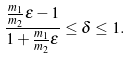Convert formula to latex. <formula><loc_0><loc_0><loc_500><loc_500>\frac { \frac { m _ { 1 } } { m _ { 2 } } \varepsilon - 1 } { 1 + \frac { m _ { 1 } } { m _ { 2 } } \varepsilon } \leq \delta \leq 1 .</formula> 